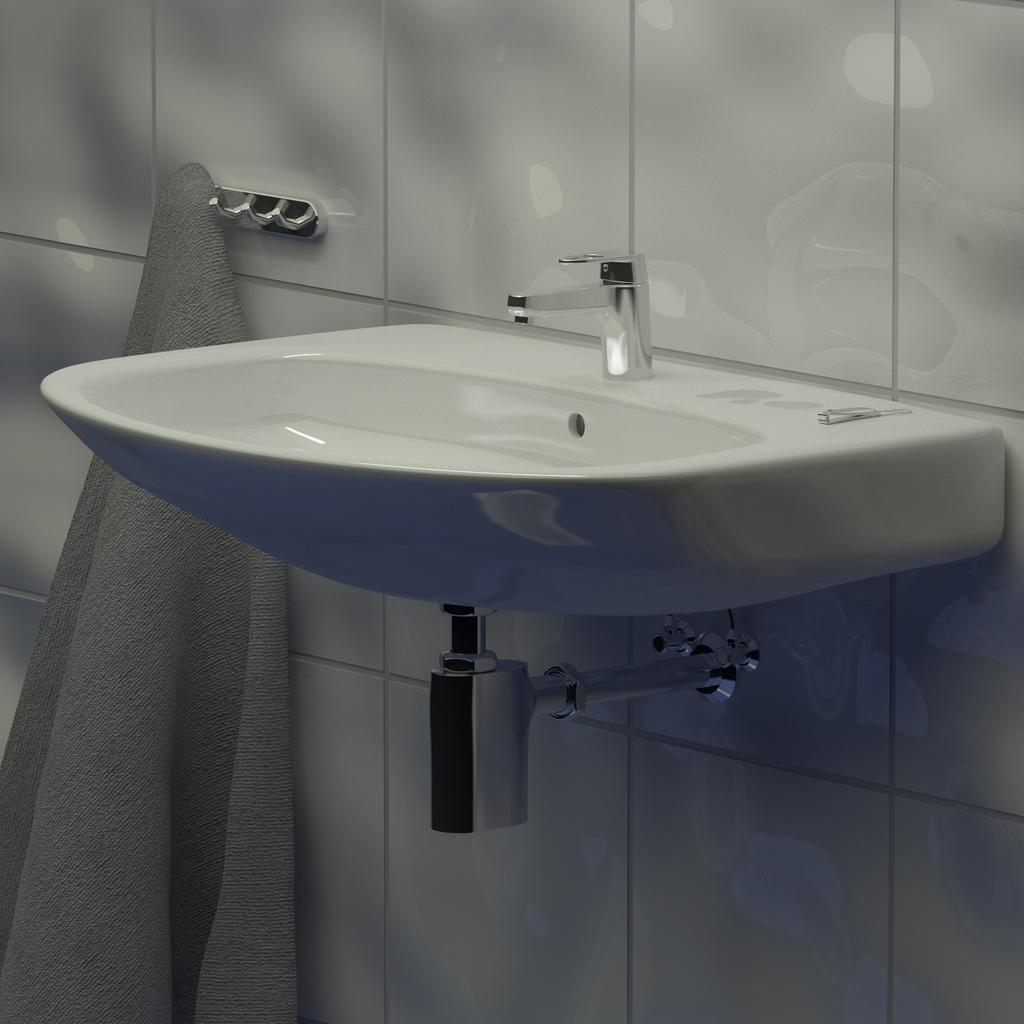What can be found in the image that is used for washing or cleaning? There is a sink in the image that can be used for washing or cleaning. What is the color of the sink? The sink is white in color. How is the sink attached in the image? The sink is attached to a wall in the image. What is used to control the flow of water in the sink? There is a tap on the sink. What is located under the sink in the image? There is a pipe under the sink. What is used to hold towels near the sink? There is a towel hanger beside the sink. Is there a towel hanging on the hanger in the image? Yes, a towel is hanging on the hanger in the image. What type of can is visible on the towel hanging near the sink? There is no can visible in the image, as it features a sink with a tap, a pipe, and a towel hanger with a towel. 